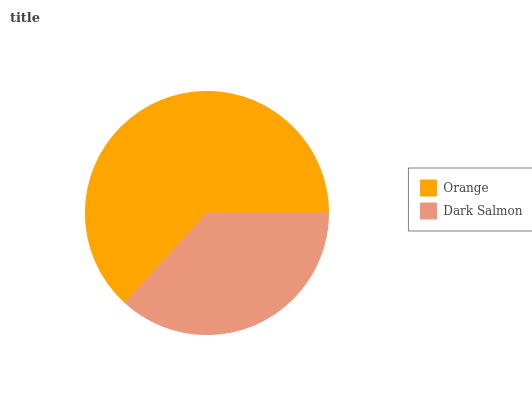Is Dark Salmon the minimum?
Answer yes or no. Yes. Is Orange the maximum?
Answer yes or no. Yes. Is Dark Salmon the maximum?
Answer yes or no. No. Is Orange greater than Dark Salmon?
Answer yes or no. Yes. Is Dark Salmon less than Orange?
Answer yes or no. Yes. Is Dark Salmon greater than Orange?
Answer yes or no. No. Is Orange less than Dark Salmon?
Answer yes or no. No. Is Orange the high median?
Answer yes or no. Yes. Is Dark Salmon the low median?
Answer yes or no. Yes. Is Dark Salmon the high median?
Answer yes or no. No. Is Orange the low median?
Answer yes or no. No. 